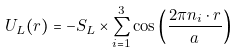Convert formula to latex. <formula><loc_0><loc_0><loc_500><loc_500>U _ { L } ( { r } ) = - S _ { L } \times \sum _ { i = 1 } ^ { 3 } \cos \left ( \frac { 2 \pi { n } _ { i } \cdot { r } } { a } \right )</formula> 